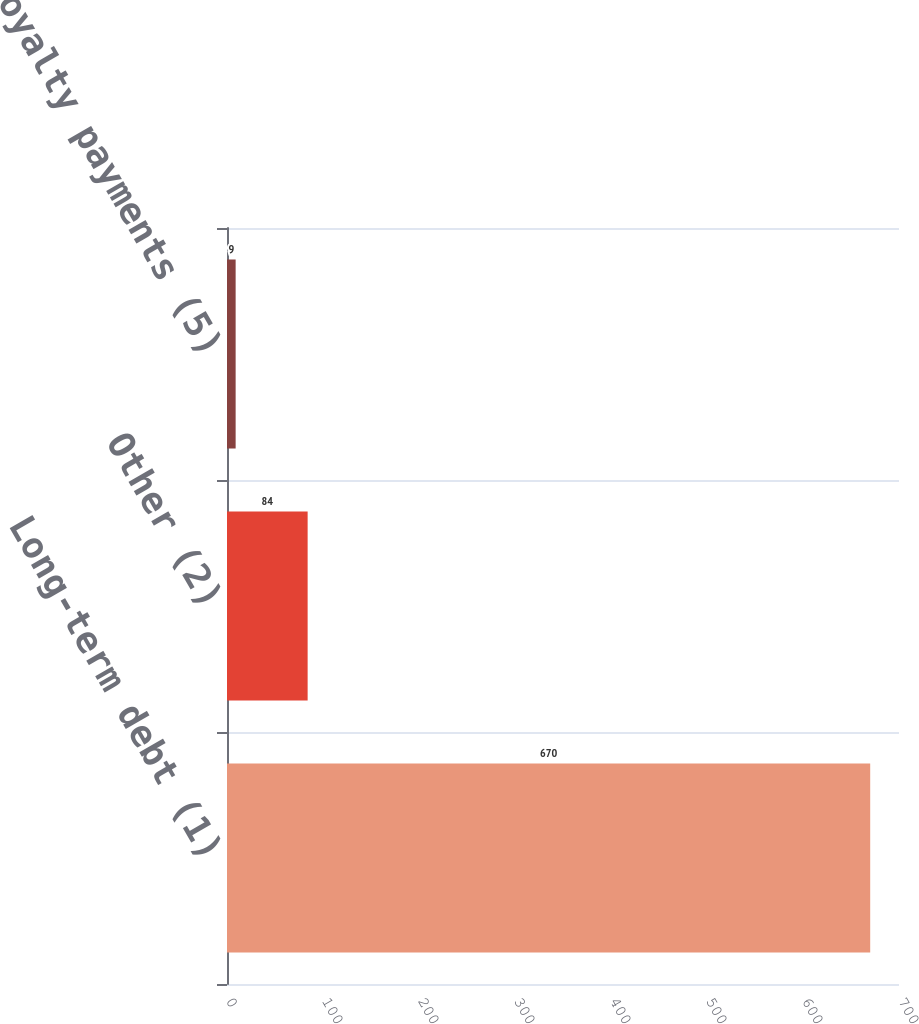<chart> <loc_0><loc_0><loc_500><loc_500><bar_chart><fcel>Long-term debt (1)<fcel>Other (2)<fcel>Minimum royalty payments (5)<nl><fcel>670<fcel>84<fcel>9<nl></chart> 